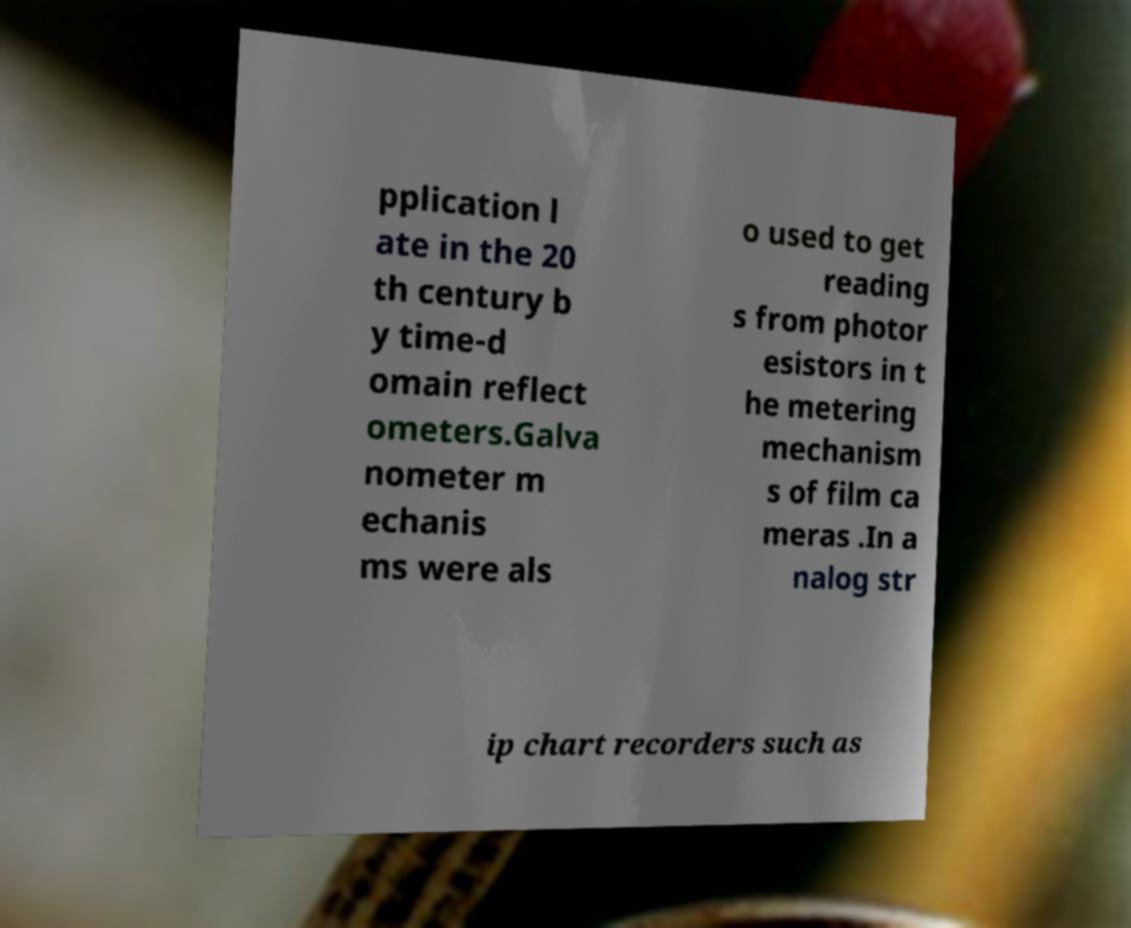There's text embedded in this image that I need extracted. Can you transcribe it verbatim? pplication l ate in the 20 th century b y time-d omain reflect ometers.Galva nometer m echanis ms were als o used to get reading s from photor esistors in t he metering mechanism s of film ca meras .In a nalog str ip chart recorders such as 